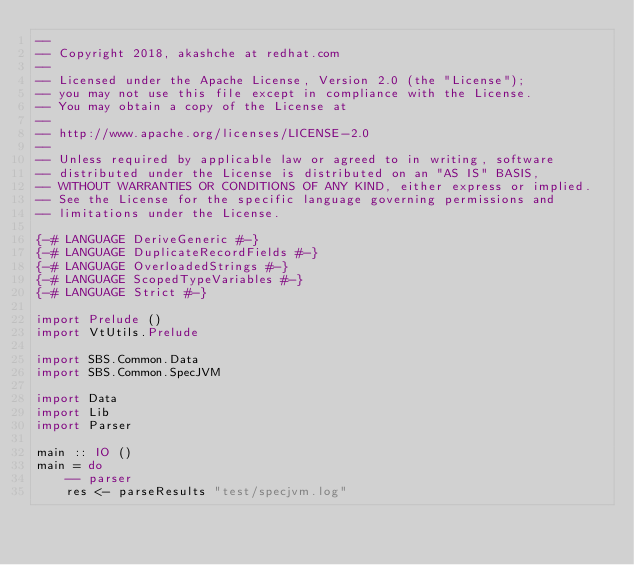Convert code to text. <code><loc_0><loc_0><loc_500><loc_500><_Haskell_>--
-- Copyright 2018, akashche at redhat.com
--
-- Licensed under the Apache License, Version 2.0 (the "License");
-- you may not use this file except in compliance with the License.
-- You may obtain a copy of the License at
--
-- http://www.apache.org/licenses/LICENSE-2.0
--
-- Unless required by applicable law or agreed to in writing, software
-- distributed under the License is distributed on an "AS IS" BASIS,
-- WITHOUT WARRANTIES OR CONDITIONS OF ANY KIND, either express or implied.
-- See the License for the specific language governing permissions and
-- limitations under the License.

{-# LANGUAGE DeriveGeneric #-}
{-# LANGUAGE DuplicateRecordFields #-}
{-# LANGUAGE OverloadedStrings #-}
{-# LANGUAGE ScopedTypeVariables #-}
{-# LANGUAGE Strict #-}

import Prelude ()
import VtUtils.Prelude

import SBS.Common.Data
import SBS.Common.SpecJVM

import Data
import Lib
import Parser

main :: IO ()
main = do
    -- parser
    res <- parseResults "test/specjvm.log"</code> 